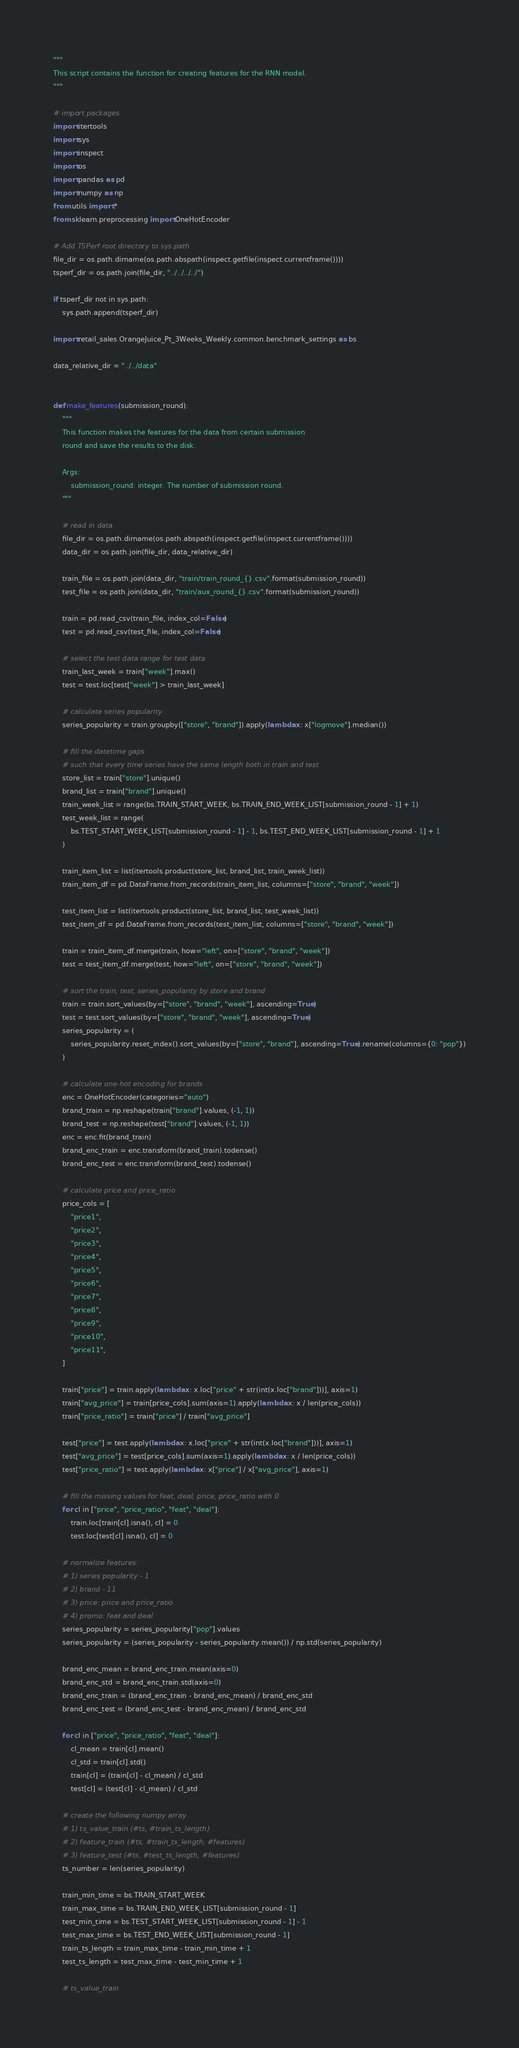<code> <loc_0><loc_0><loc_500><loc_500><_Python_>"""
This script contains the function for creating features for the RNN model.
"""

# import packages
import itertools
import sys
import inspect
import os
import pandas as pd
import numpy as np
from utils import *
from sklearn.preprocessing import OneHotEncoder

# Add TSPerf root directory to sys.path
file_dir = os.path.dirname(os.path.abspath(inspect.getfile(inspect.currentframe())))
tsperf_dir = os.path.join(file_dir, "../../../../")

if tsperf_dir not in sys.path:
    sys.path.append(tsperf_dir)

import retail_sales.OrangeJuice_Pt_3Weeks_Weekly.common.benchmark_settings as bs

data_relative_dir = "../../data"


def make_features(submission_round):
    """
    This function makes the features for the data from certain submission
    round and save the results to the disk.

    Args:
        submission_round: integer. The number of submission round.     
    """

    # read in data
    file_dir = os.path.dirname(os.path.abspath(inspect.getfile(inspect.currentframe())))
    data_dir = os.path.join(file_dir, data_relative_dir)

    train_file = os.path.join(data_dir, "train/train_round_{}.csv".format(submission_round))
    test_file = os.path.join(data_dir, "train/aux_round_{}.csv".format(submission_round))

    train = pd.read_csv(train_file, index_col=False)
    test = pd.read_csv(test_file, index_col=False)

    # select the test data range for test data
    train_last_week = train["week"].max()
    test = test.loc[test["week"] > train_last_week]

    # calculate series popularity
    series_popularity = train.groupby(["store", "brand"]).apply(lambda x: x["logmove"].median())

    # fill the datetime gaps
    # such that every time series have the same length both in train and test
    store_list = train["store"].unique()
    brand_list = train["brand"].unique()
    train_week_list = range(bs.TRAIN_START_WEEK, bs.TRAIN_END_WEEK_LIST[submission_round - 1] + 1)
    test_week_list = range(
        bs.TEST_START_WEEK_LIST[submission_round - 1] - 1, bs.TEST_END_WEEK_LIST[submission_round - 1] + 1
    )

    train_item_list = list(itertools.product(store_list, brand_list, train_week_list))
    train_item_df = pd.DataFrame.from_records(train_item_list, columns=["store", "brand", "week"])

    test_item_list = list(itertools.product(store_list, brand_list, test_week_list))
    test_item_df = pd.DataFrame.from_records(test_item_list, columns=["store", "brand", "week"])

    train = train_item_df.merge(train, how="left", on=["store", "brand", "week"])
    test = test_item_df.merge(test, how="left", on=["store", "brand", "week"])

    # sort the train, test, series_popularity by store and brand
    train = train.sort_values(by=["store", "brand", "week"], ascending=True)
    test = test.sort_values(by=["store", "brand", "week"], ascending=True)
    series_popularity = (
        series_popularity.reset_index().sort_values(by=["store", "brand"], ascending=True).rename(columns={0: "pop"})
    )

    # calculate one-hot encoding for brands
    enc = OneHotEncoder(categories="auto")
    brand_train = np.reshape(train["brand"].values, (-1, 1))
    brand_test = np.reshape(test["brand"].values, (-1, 1))
    enc = enc.fit(brand_train)
    brand_enc_train = enc.transform(brand_train).todense()
    brand_enc_test = enc.transform(brand_test).todense()

    # calculate price and price_ratio
    price_cols = [
        "price1",
        "price2",
        "price3",
        "price4",
        "price5",
        "price6",
        "price7",
        "price8",
        "price9",
        "price10",
        "price11",
    ]

    train["price"] = train.apply(lambda x: x.loc["price" + str(int(x.loc["brand"]))], axis=1)
    train["avg_price"] = train[price_cols].sum(axis=1).apply(lambda x: x / len(price_cols))
    train["price_ratio"] = train["price"] / train["avg_price"]

    test["price"] = test.apply(lambda x: x.loc["price" + str(int(x.loc["brand"]))], axis=1)
    test["avg_price"] = test[price_cols].sum(axis=1).apply(lambda x: x / len(price_cols))
    test["price_ratio"] = test.apply(lambda x: x["price"] / x["avg_price"], axis=1)

    # fill the missing values for feat, deal, price, price_ratio with 0
    for cl in ["price", "price_ratio", "feat", "deal"]:
        train.loc[train[cl].isna(), cl] = 0
        test.loc[test[cl].isna(), cl] = 0

    # normalize features:
    # 1) series popularity - 1
    # 2) brand - 11
    # 3) price: price and price_ratio
    # 4) promo: feat and deal
    series_popularity = series_popularity["pop"].values
    series_popularity = (series_popularity - series_popularity.mean()) / np.std(series_popularity)

    brand_enc_mean = brand_enc_train.mean(axis=0)
    brand_enc_std = brand_enc_train.std(axis=0)
    brand_enc_train = (brand_enc_train - brand_enc_mean) / brand_enc_std
    brand_enc_test = (brand_enc_test - brand_enc_mean) / brand_enc_std

    for cl in ["price", "price_ratio", "feat", "deal"]:
        cl_mean = train[cl].mean()
        cl_std = train[cl].std()
        train[cl] = (train[cl] - cl_mean) / cl_std
        test[cl] = (test[cl] - cl_mean) / cl_std

    # create the following numpy array
    # 1) ts_value_train (#ts, #train_ts_length)
    # 2) feature_train (#ts, #train_ts_length, #features)
    # 3) feature_test (#ts, #test_ts_length, #features)
    ts_number = len(series_popularity)

    train_min_time = bs.TRAIN_START_WEEK
    train_max_time = bs.TRAIN_END_WEEK_LIST[submission_round - 1]
    test_min_time = bs.TEST_START_WEEK_LIST[submission_round - 1] - 1
    test_max_time = bs.TEST_END_WEEK_LIST[submission_round - 1]
    train_ts_length = train_max_time - train_min_time + 1
    test_ts_length = test_max_time - test_min_time + 1

    # ts_value_train</code> 